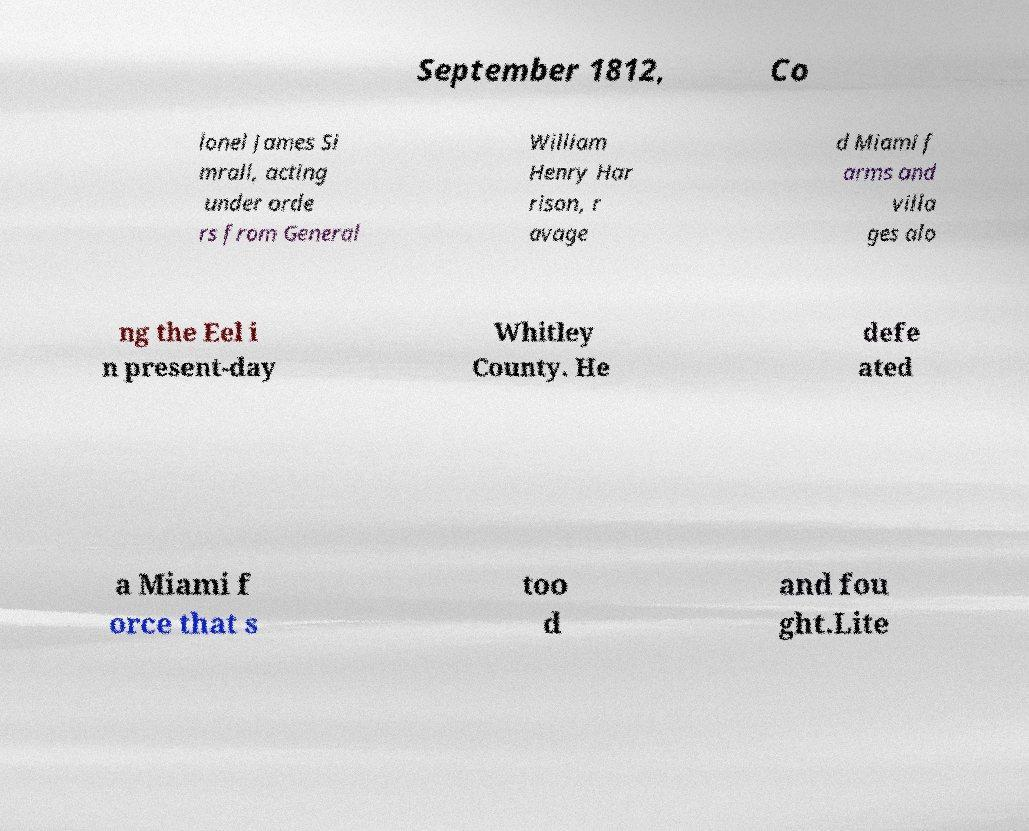Can you accurately transcribe the text from the provided image for me? September 1812, Co lonel James Si mrall, acting under orde rs from General William Henry Har rison, r avage d Miami f arms and villa ges alo ng the Eel i n present-day Whitley County. He defe ated a Miami f orce that s too d and fou ght.Lite 